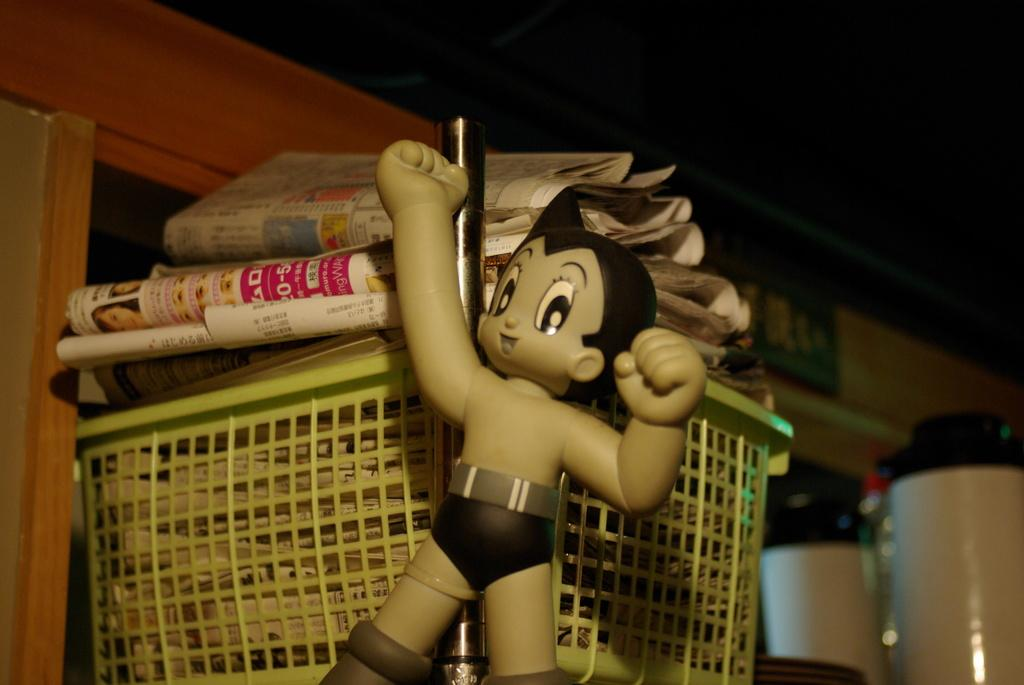What is the main object in the center of the image? There is a toy in the center of the image. What can be seen in the background of the image? There is a basket in the background of the image, and papers are placed in the basket. What is the wall visible in the background of the image made of? The facts provided do not specify the material of the wall. How many objects are visible in the background of the image? Two objects are visible in the background of the image: a basket and a wall. How does the stream flow through the image? There is no stream present in the image. 